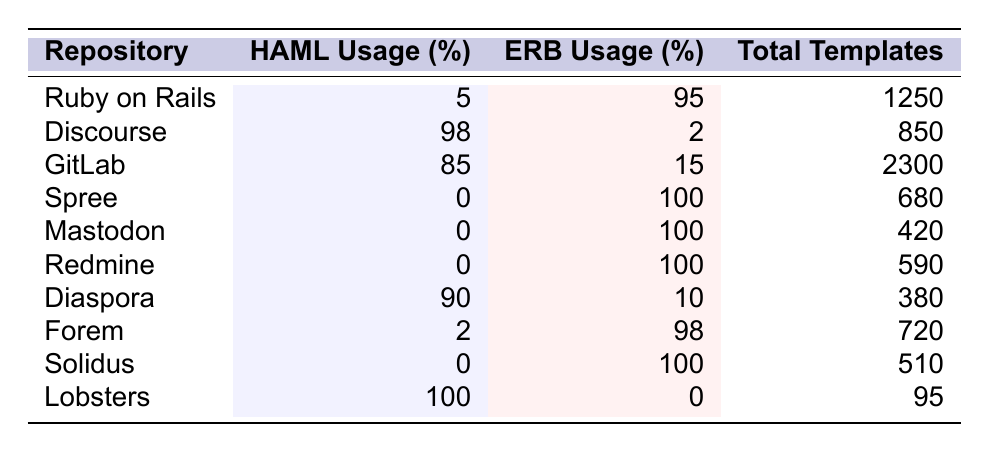What is the HAML usage percentage for the Ruby on Rails repository? The table states that the HAML usage percentage for Ruby on Rails is explicitly listed as 5%.
Answer: 5% Which repository has the highest ERB usage percentage? By scanning the ERB usage column, Discourse has the highest ERB usage percentage at 2%.
Answer: Discourse What is the total number of templates used in the GitLab repository? The table indicates that GitLab has a total of 2300 templates.
Answer: 2300 How many repositories use HAML at a percentage of 0%? Looking through the HAML usage column, there are three repositories: Spree, Mastodon, and Redmine that have a HAML usage of 0%.
Answer: 3 What is the average HAML usage percentage across all repositories listed? To find the average, first sum the HAML usage percentages: 5 + 98 + 85 + 0 + 0 + 0 + 90 + 2 + 0 + 100 = 380. Then divide by the number of repositories (10): 380/10 = 38%.
Answer: 38% Is it true that all repositories listed have some degree of HAML usage? By checking the HAML usage percentages, Spree, Mastodon, Redmine, and Solidus all have 0% HAML usage, so the statement is false.
Answer: No Which repository has the least amount of total templates, and how many does it have? By comparing the total templates for each repository, Lobsters has the least with 95 templates.
Answer: Lobsters, 95 If you combine the HAML usage percentages of Discourse and GitLab, what is the resulting percentage? Adding the HAML usage percentages gives us 98% for Discourse and 85% for GitLab: 98 + 85 = 183%.
Answer: 183% Which repository has a HAML usage percentage closest to the average HAML usage percentage? The average is calculated as 38%. The repository closest to this average in HAML usage is GitLab at 85%.
Answer: GitLab Are there any repositories with an ERB usage percentage below 10%? Scanning the ERB usage percentage, only Discourse (2%) and Diaspora (10%) have percentages below 10%.
Answer: Yes, Discourse 